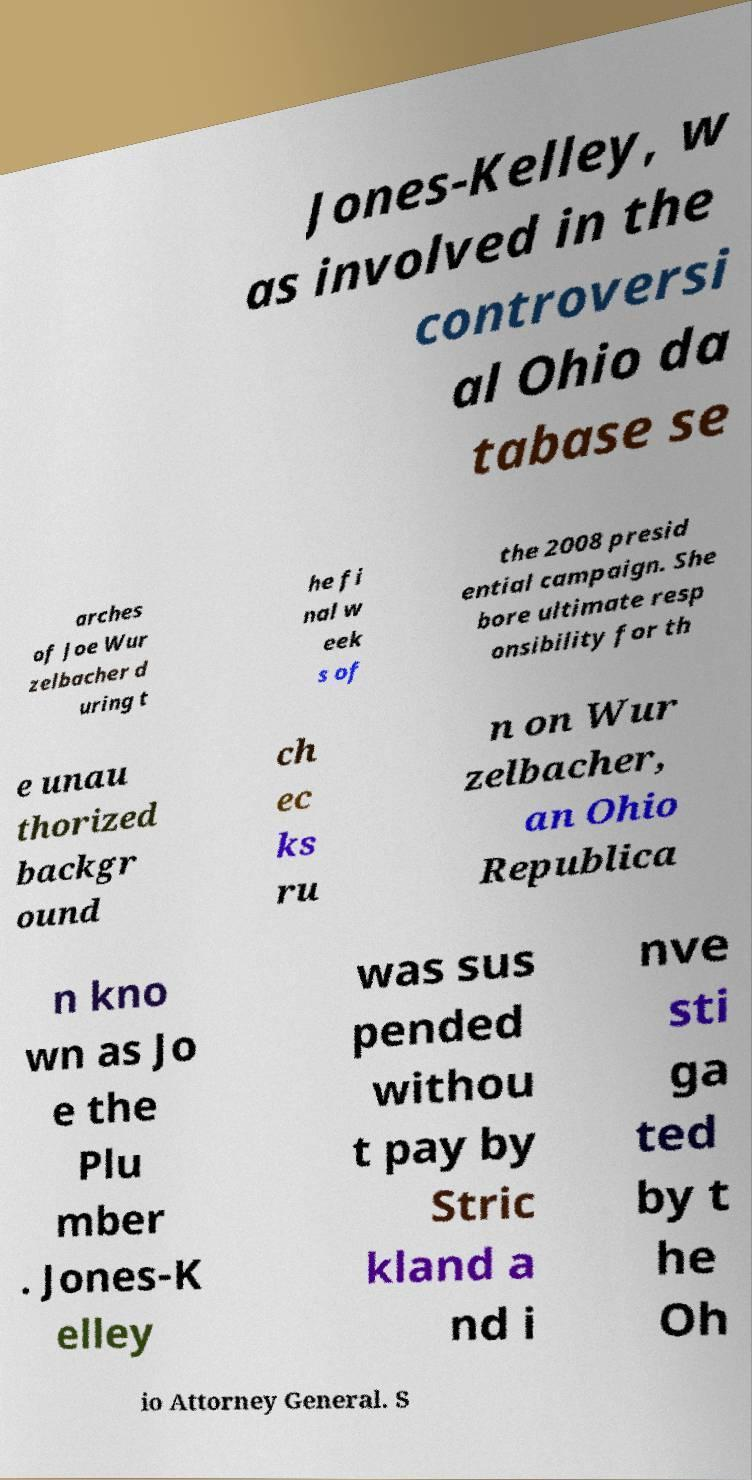Can you read and provide the text displayed in the image?This photo seems to have some interesting text. Can you extract and type it out for me? Jones-Kelley, w as involved in the controversi al Ohio da tabase se arches of Joe Wur zelbacher d uring t he fi nal w eek s of the 2008 presid ential campaign. She bore ultimate resp onsibility for th e unau thorized backgr ound ch ec ks ru n on Wur zelbacher, an Ohio Republica n kno wn as Jo e the Plu mber . Jones-K elley was sus pended withou t pay by Stric kland a nd i nve sti ga ted by t he Oh io Attorney General. S 